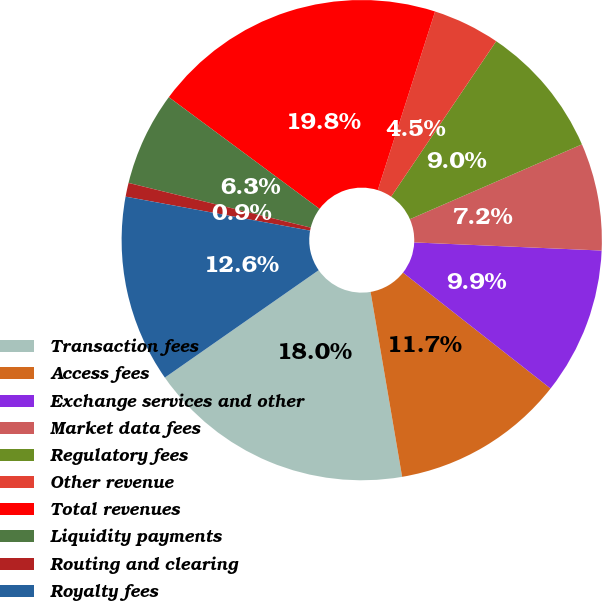<chart> <loc_0><loc_0><loc_500><loc_500><pie_chart><fcel>Transaction fees<fcel>Access fees<fcel>Exchange services and other<fcel>Market data fees<fcel>Regulatory fees<fcel>Other revenue<fcel>Total revenues<fcel>Liquidity payments<fcel>Routing and clearing<fcel>Royalty fees<nl><fcel>17.99%<fcel>11.71%<fcel>9.91%<fcel>7.22%<fcel>9.01%<fcel>4.52%<fcel>19.79%<fcel>6.32%<fcel>0.93%<fcel>12.6%<nl></chart> 